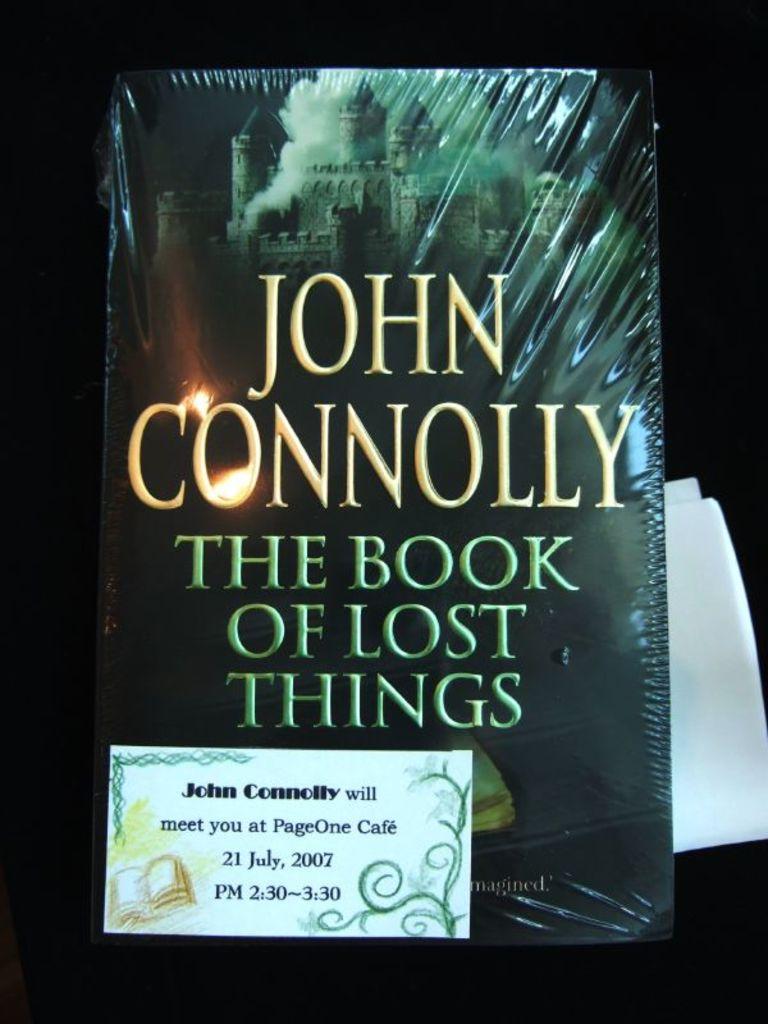Who is the author of the book?
Provide a short and direct response. John connolly. What is the title of the book?
Offer a very short reply. The book of lost things. 